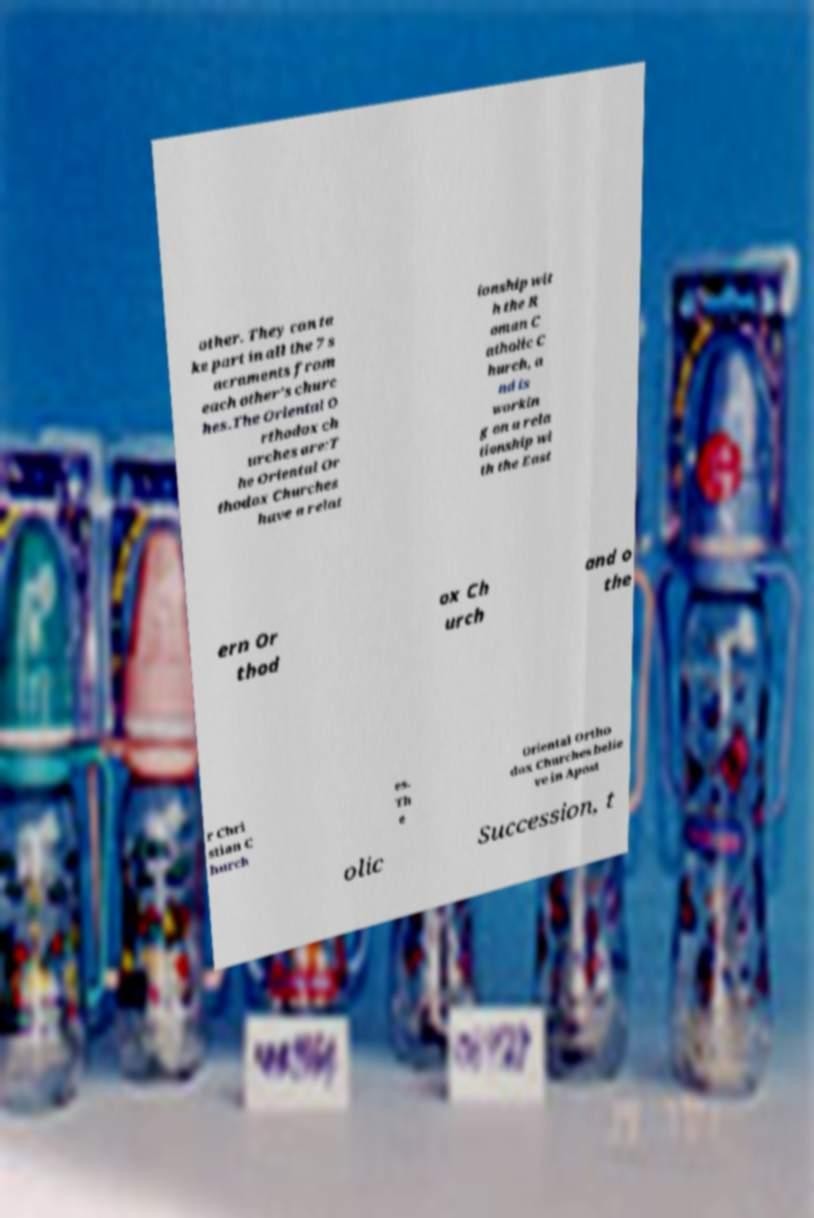Could you extract and type out the text from this image? other. They can ta ke part in all the 7 s acraments from each other's churc hes.The Oriental O rthodox ch urches are:T he Oriental Or thodox Churches have a relat ionship wit h the R oman C atholic C hurch, a nd is workin g on a rela tionship wi th the East ern Or thod ox Ch urch and o the r Chri stian C hurch es. Th e Oriental Ortho dox Churches belie ve in Apost olic Succession, t 